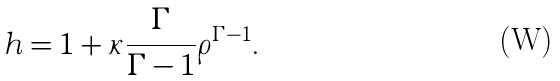Convert formula to latex. <formula><loc_0><loc_0><loc_500><loc_500>h = 1 + \kappa \frac { \Gamma } { \Gamma - 1 } \rho ^ { \Gamma - 1 } .</formula> 